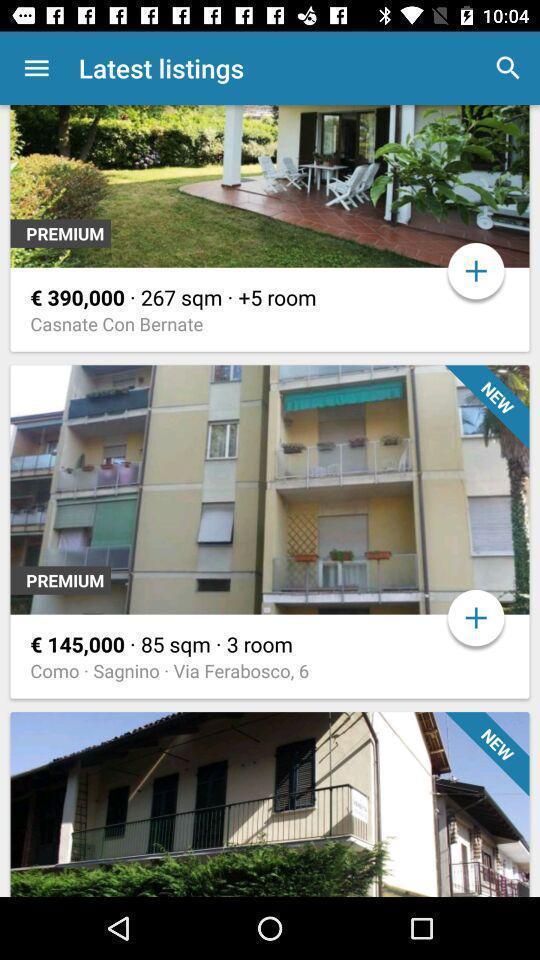Explain what's happening in this screen capture. Screen displaying page. 